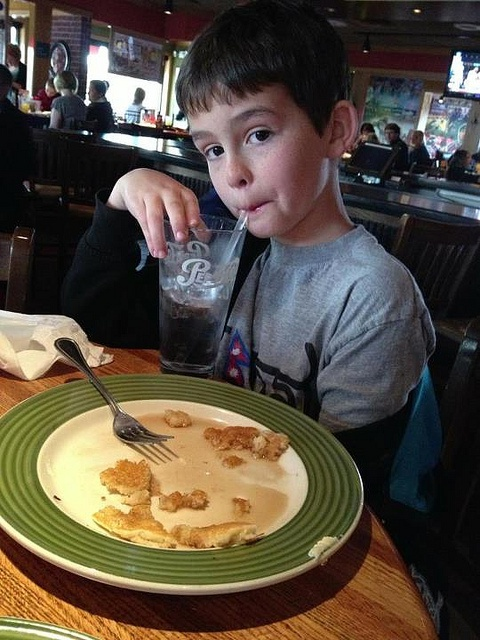Describe the objects in this image and their specific colors. I can see dining table in gray, olive, black, tan, and brown tones, people in gray, black, darkgray, and maroon tones, cup in gray, black, and darkgray tones, chair in gray and black tones, and people in gray, black, and blue tones in this image. 